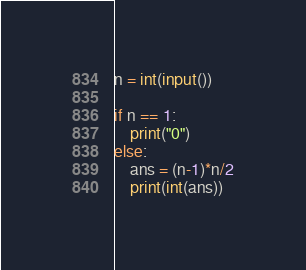Convert code to text. <code><loc_0><loc_0><loc_500><loc_500><_Python_>n = int(input())

if n == 1:
    print("0")
else:
    ans = (n-1)*n/2
    print(int(ans))</code> 